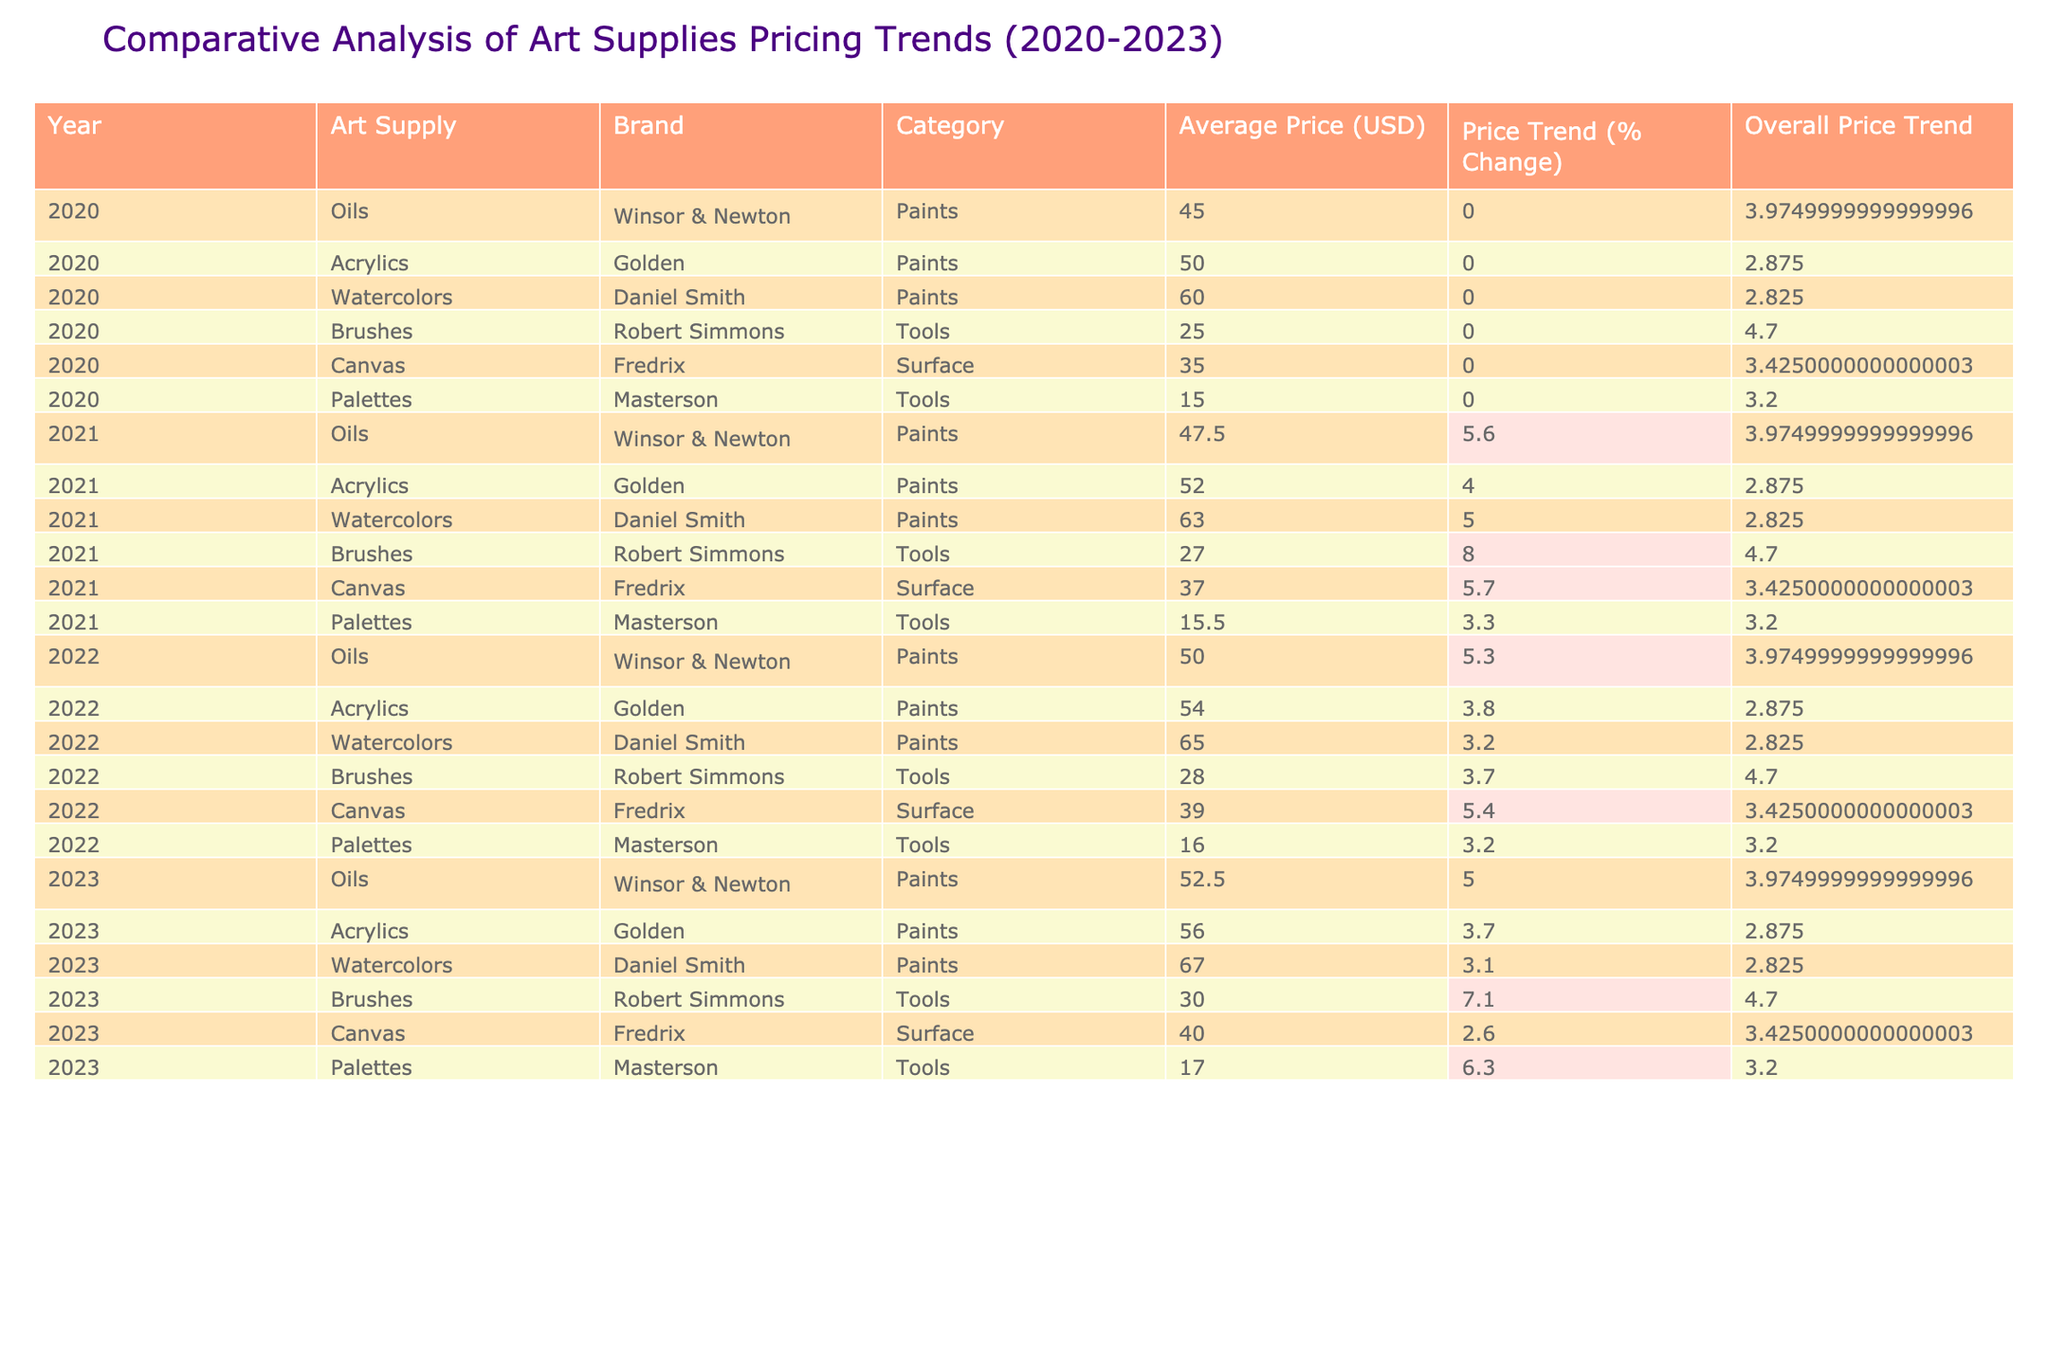What was the average price of watercolors in 2021? In 2021, the average price of watercolors (Daniel Smith) is listed as 63.00 USD. There is only one value for watercolors in 2021, so the average is simply this value.
Answer: 63.00 What is the total price trend percentage change for acrylics from 2020 to 2023? The price trend changes for acrylics are: 0.0% in 2020 to 4.0% in 2021, then 3.8% in 2022, and finally 3.7% in 2023. To find the total change, we calculate: 4.0 + 3.8 + 3.7 = 11.5. Therefore, the total percentage change is 11.5%.
Answer: 11.5% Did the price of brushes increase every year from 2020 to 2023? The price of brushes increased from 25.00 USD in 2020 to 27.00 USD in 2021, then to 28.00 USD in 2022, and finally to 30.00 USD in 2023. Hence, every year shows an increase.
Answer: Yes Which art supply had the highest average price in 2023, and what was it? Looking at the 2023 data, the average prices are: Oils (52.50), Acrylics (56.00), Watercolors (67.00), Brushes (30.00), Canvas (40.00), and Palettes (17.00). Watercolors at 67.00 USD is the highest.
Answer: Watercolors, 67.00 USD What was the average price trend percentage change for canvases from 2020 to 2023? The changes for canvas are: 0.0% in 2020, 5.7% in 2021, 5.4% in 2022, and 2.6% in 2023. To find the average change, we calculate: (0.0 + 5.7 + 5.4 + 2.6) / 4 = 3.425.
Answer: 3.43 What is the overall price trend percentage change for palettes across the four years? The changes for palettes are: 0.0% in 2020, 3.3% in 2021, 3.2% in 2022, and 6.3% in 2023. To find the overall trend, calculate the average: (0.0 + 3.3 + 3.2 + 6.3) / 4 = 3.225.
Answer: 3.23 Which brand of oil paints experienced the highest average price increase from 2020 to 2023? The price for Winsor & Newton oils increased from 45.00 USD in 2020 to 52.50 USD in 2023, which is an increase of 7.50 USD. No other oil brand is listed, so it's the only one.
Answer: Winsor & Newton, 7.50 USD How much did the price of watercolors increase from 2020 to 2022? In 2020, watercolors cost 60.00 USD, and in 2022 they cost 65.00 USD. The increase is calculated as 65.00 - 60.00 = 5.00 USD.
Answer: 5.00 USD Which tool had the lowest average price in the year 2022? The tools listed for 2022 are Brushes (28.00) and Palettes (16.00). Since 16.00 is lower than 28.00, palettes had the lowest average price.
Answer: Palettes, 16.00 What is the difference in prices between acrylics in 2021 and 2022? The average price for acrylics in 2021 is 52.00 USD and in 2022 it's 54.00 USD. The difference is 54.00 - 52.00 = 2.00 USD.
Answer: 2.00 USD 